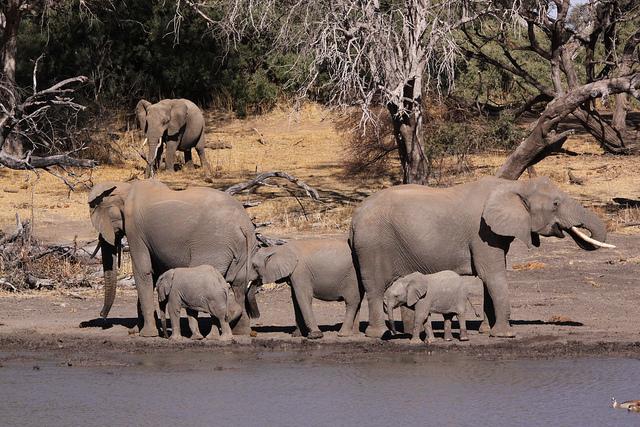How many elephants are there?
Give a very brief answer. 6. What direction are the elephants heading?
Write a very short answer. East. How many young elephants are there?
Give a very brief answer. 4. How many different types of animals are there?
Keep it brief. 1. How many elephants?
Quick response, please. 6. How many animals are there?
Answer briefly. 6. Do the elephants drink the water?
Keep it brief. Yes. How many elephants are seen?
Be succinct. 6. What are the elephants standing in?
Concise answer only. Mud. 